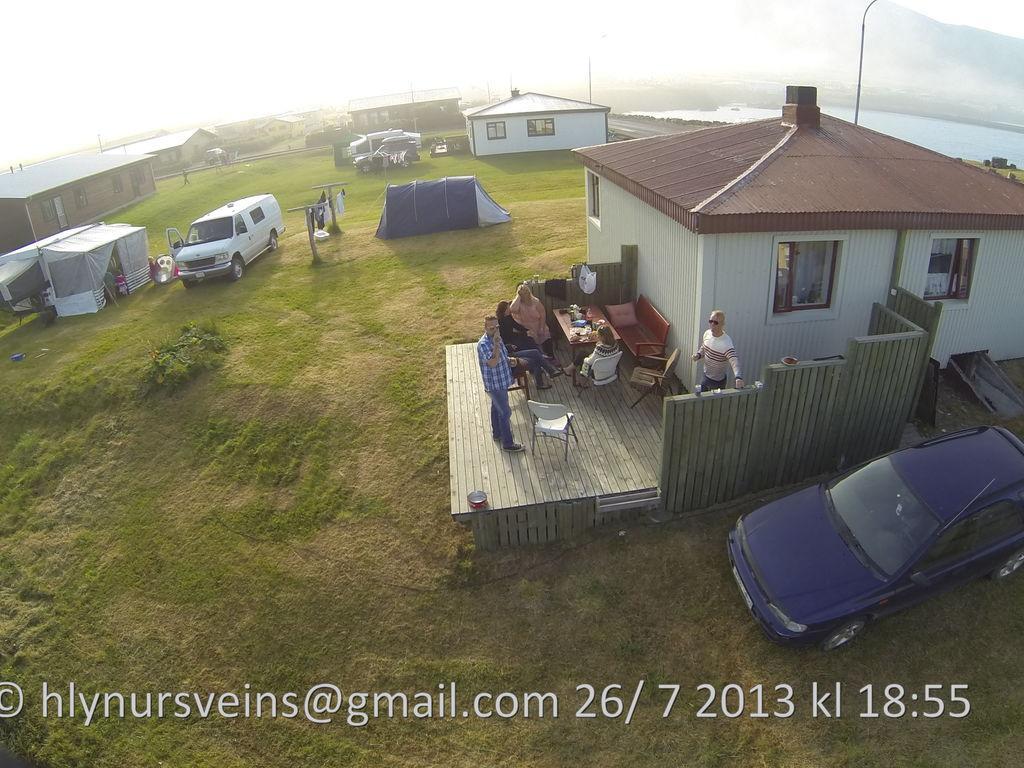Can you describe this image briefly? In this image we can see there is grass land and there are so many buildings and people standing there also there are so many vehicles standing beside. At the back there is a lake and mountains. 